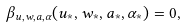<formula> <loc_0><loc_0><loc_500><loc_500>\beta _ { u , w , a , \alpha } ( u _ { * } , w _ { * } , a _ { * } , \alpha _ { * } ) = 0 ,</formula> 